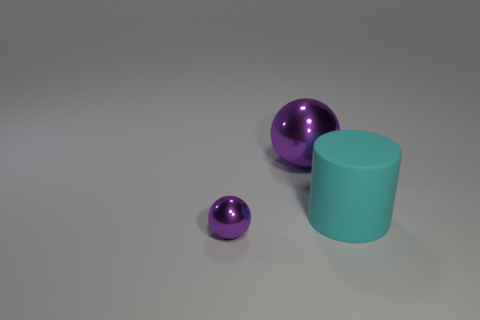Add 1 purple metal spheres. How many objects exist? 4 Subtract all cylinders. How many objects are left? 2 Subtract all brown cubes. Subtract all large cyan cylinders. How many objects are left? 2 Add 1 small shiny spheres. How many small shiny spheres are left? 2 Add 3 big green rubber cubes. How many big green rubber cubes exist? 3 Subtract 0 yellow cylinders. How many objects are left? 3 